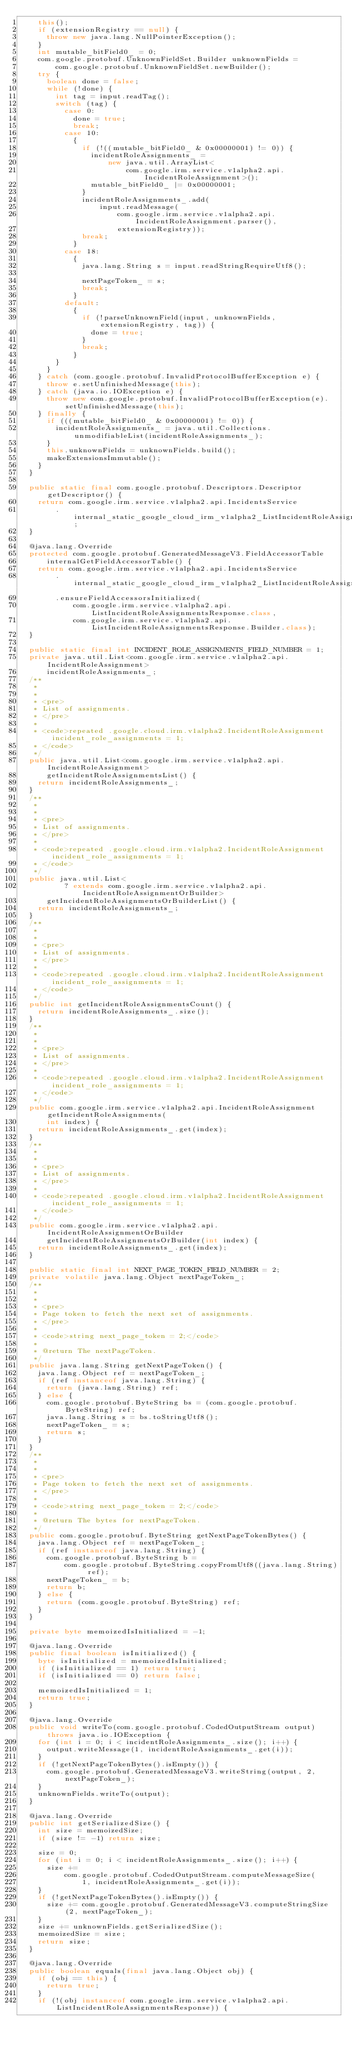Convert code to text. <code><loc_0><loc_0><loc_500><loc_500><_Java_>    this();
    if (extensionRegistry == null) {
      throw new java.lang.NullPointerException();
    }
    int mutable_bitField0_ = 0;
    com.google.protobuf.UnknownFieldSet.Builder unknownFields =
        com.google.protobuf.UnknownFieldSet.newBuilder();
    try {
      boolean done = false;
      while (!done) {
        int tag = input.readTag();
        switch (tag) {
          case 0:
            done = true;
            break;
          case 10:
            {
              if (!((mutable_bitField0_ & 0x00000001) != 0)) {
                incidentRoleAssignments_ =
                    new java.util.ArrayList<
                        com.google.irm.service.v1alpha2.api.IncidentRoleAssignment>();
                mutable_bitField0_ |= 0x00000001;
              }
              incidentRoleAssignments_.add(
                  input.readMessage(
                      com.google.irm.service.v1alpha2.api.IncidentRoleAssignment.parser(),
                      extensionRegistry));
              break;
            }
          case 18:
            {
              java.lang.String s = input.readStringRequireUtf8();

              nextPageToken_ = s;
              break;
            }
          default:
            {
              if (!parseUnknownField(input, unknownFields, extensionRegistry, tag)) {
                done = true;
              }
              break;
            }
        }
      }
    } catch (com.google.protobuf.InvalidProtocolBufferException e) {
      throw e.setUnfinishedMessage(this);
    } catch (java.io.IOException e) {
      throw new com.google.protobuf.InvalidProtocolBufferException(e).setUnfinishedMessage(this);
    } finally {
      if (((mutable_bitField0_ & 0x00000001) != 0)) {
        incidentRoleAssignments_ = java.util.Collections.unmodifiableList(incidentRoleAssignments_);
      }
      this.unknownFields = unknownFields.build();
      makeExtensionsImmutable();
    }
  }

  public static final com.google.protobuf.Descriptors.Descriptor getDescriptor() {
    return com.google.irm.service.v1alpha2.api.IncidentsService
        .internal_static_google_cloud_irm_v1alpha2_ListIncidentRoleAssignmentsResponse_descriptor;
  }

  @java.lang.Override
  protected com.google.protobuf.GeneratedMessageV3.FieldAccessorTable
      internalGetFieldAccessorTable() {
    return com.google.irm.service.v1alpha2.api.IncidentsService
        .internal_static_google_cloud_irm_v1alpha2_ListIncidentRoleAssignmentsResponse_fieldAccessorTable
        .ensureFieldAccessorsInitialized(
            com.google.irm.service.v1alpha2.api.ListIncidentRoleAssignmentsResponse.class,
            com.google.irm.service.v1alpha2.api.ListIncidentRoleAssignmentsResponse.Builder.class);
  }

  public static final int INCIDENT_ROLE_ASSIGNMENTS_FIELD_NUMBER = 1;
  private java.util.List<com.google.irm.service.v1alpha2.api.IncidentRoleAssignment>
      incidentRoleAssignments_;
  /**
   *
   *
   * <pre>
   * List of assignments.
   * </pre>
   *
   * <code>repeated .google.cloud.irm.v1alpha2.IncidentRoleAssignment incident_role_assignments = 1;
   * </code>
   */
  public java.util.List<com.google.irm.service.v1alpha2.api.IncidentRoleAssignment>
      getIncidentRoleAssignmentsList() {
    return incidentRoleAssignments_;
  }
  /**
   *
   *
   * <pre>
   * List of assignments.
   * </pre>
   *
   * <code>repeated .google.cloud.irm.v1alpha2.IncidentRoleAssignment incident_role_assignments = 1;
   * </code>
   */
  public java.util.List<
          ? extends com.google.irm.service.v1alpha2.api.IncidentRoleAssignmentOrBuilder>
      getIncidentRoleAssignmentsOrBuilderList() {
    return incidentRoleAssignments_;
  }
  /**
   *
   *
   * <pre>
   * List of assignments.
   * </pre>
   *
   * <code>repeated .google.cloud.irm.v1alpha2.IncidentRoleAssignment incident_role_assignments = 1;
   * </code>
   */
  public int getIncidentRoleAssignmentsCount() {
    return incidentRoleAssignments_.size();
  }
  /**
   *
   *
   * <pre>
   * List of assignments.
   * </pre>
   *
   * <code>repeated .google.cloud.irm.v1alpha2.IncidentRoleAssignment incident_role_assignments = 1;
   * </code>
   */
  public com.google.irm.service.v1alpha2.api.IncidentRoleAssignment getIncidentRoleAssignments(
      int index) {
    return incidentRoleAssignments_.get(index);
  }
  /**
   *
   *
   * <pre>
   * List of assignments.
   * </pre>
   *
   * <code>repeated .google.cloud.irm.v1alpha2.IncidentRoleAssignment incident_role_assignments = 1;
   * </code>
   */
  public com.google.irm.service.v1alpha2.api.IncidentRoleAssignmentOrBuilder
      getIncidentRoleAssignmentsOrBuilder(int index) {
    return incidentRoleAssignments_.get(index);
  }

  public static final int NEXT_PAGE_TOKEN_FIELD_NUMBER = 2;
  private volatile java.lang.Object nextPageToken_;
  /**
   *
   *
   * <pre>
   * Page token to fetch the next set of assignments.
   * </pre>
   *
   * <code>string next_page_token = 2;</code>
   *
   * @return The nextPageToken.
   */
  public java.lang.String getNextPageToken() {
    java.lang.Object ref = nextPageToken_;
    if (ref instanceof java.lang.String) {
      return (java.lang.String) ref;
    } else {
      com.google.protobuf.ByteString bs = (com.google.protobuf.ByteString) ref;
      java.lang.String s = bs.toStringUtf8();
      nextPageToken_ = s;
      return s;
    }
  }
  /**
   *
   *
   * <pre>
   * Page token to fetch the next set of assignments.
   * </pre>
   *
   * <code>string next_page_token = 2;</code>
   *
   * @return The bytes for nextPageToken.
   */
  public com.google.protobuf.ByteString getNextPageTokenBytes() {
    java.lang.Object ref = nextPageToken_;
    if (ref instanceof java.lang.String) {
      com.google.protobuf.ByteString b =
          com.google.protobuf.ByteString.copyFromUtf8((java.lang.String) ref);
      nextPageToken_ = b;
      return b;
    } else {
      return (com.google.protobuf.ByteString) ref;
    }
  }

  private byte memoizedIsInitialized = -1;

  @java.lang.Override
  public final boolean isInitialized() {
    byte isInitialized = memoizedIsInitialized;
    if (isInitialized == 1) return true;
    if (isInitialized == 0) return false;

    memoizedIsInitialized = 1;
    return true;
  }

  @java.lang.Override
  public void writeTo(com.google.protobuf.CodedOutputStream output) throws java.io.IOException {
    for (int i = 0; i < incidentRoleAssignments_.size(); i++) {
      output.writeMessage(1, incidentRoleAssignments_.get(i));
    }
    if (!getNextPageTokenBytes().isEmpty()) {
      com.google.protobuf.GeneratedMessageV3.writeString(output, 2, nextPageToken_);
    }
    unknownFields.writeTo(output);
  }

  @java.lang.Override
  public int getSerializedSize() {
    int size = memoizedSize;
    if (size != -1) return size;

    size = 0;
    for (int i = 0; i < incidentRoleAssignments_.size(); i++) {
      size +=
          com.google.protobuf.CodedOutputStream.computeMessageSize(
              1, incidentRoleAssignments_.get(i));
    }
    if (!getNextPageTokenBytes().isEmpty()) {
      size += com.google.protobuf.GeneratedMessageV3.computeStringSize(2, nextPageToken_);
    }
    size += unknownFields.getSerializedSize();
    memoizedSize = size;
    return size;
  }

  @java.lang.Override
  public boolean equals(final java.lang.Object obj) {
    if (obj == this) {
      return true;
    }
    if (!(obj instanceof com.google.irm.service.v1alpha2.api.ListIncidentRoleAssignmentsResponse)) {</code> 